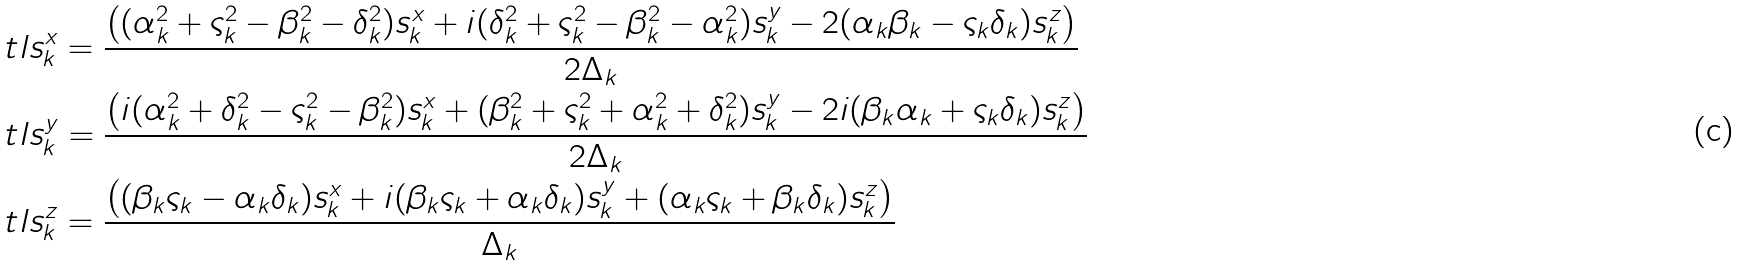Convert formula to latex. <formula><loc_0><loc_0><loc_500><loc_500>& \ t l { s } ^ { x } _ { k } = \frac { \left ( ( \alpha ^ { 2 } _ { k } + \varsigma ^ { 2 } _ { k } - \beta ^ { 2 } _ { k } - \delta ^ { 2 } _ { k } ) s ^ { x } _ { k } + i ( \delta ^ { 2 } _ { k } + \varsigma ^ { 2 } _ { k } - \beta ^ { 2 } _ { k } - \alpha ^ { 2 } _ { k } ) s ^ { y } _ { k } - 2 ( \alpha _ { k } \beta _ { k } - \varsigma _ { k } \delta _ { k } ) s ^ { z } _ { k } \right ) } { 2 \Delta _ { k } } \\ & \ t l { s } ^ { y } _ { k } = \frac { \left ( i ( \alpha ^ { 2 } _ { k } + \delta ^ { 2 } _ { k } - \varsigma ^ { 2 } _ { k } - \beta ^ { 2 } _ { k } ) s ^ { x } _ { k } + ( \beta ^ { 2 } _ { k } + \varsigma ^ { 2 } _ { k } + \alpha ^ { 2 } _ { k } + \delta ^ { 2 } _ { k } ) s ^ { y } _ { k } - 2 i ( \beta _ { k } \alpha _ { k } + \varsigma _ { k } \delta _ { k } ) s ^ { z } _ { k } \right ) } { 2 \Delta _ { k } } \\ & \ t l { s } ^ { z } _ { k } = \frac { \left ( ( \beta _ { k } \varsigma _ { k } - \alpha _ { k } \delta _ { k } ) s ^ { x } _ { k } + i ( \beta _ { k } \varsigma _ { k } + \alpha _ { k } \delta _ { k } ) s ^ { y } _ { k } + ( \alpha _ { k } \varsigma _ { k } + \beta _ { k } \delta _ { k } ) s ^ { z } _ { k } \right ) } { \Delta _ { k } }</formula> 